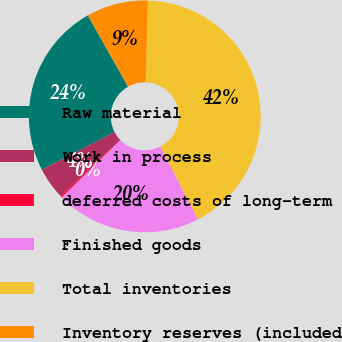Convert chart. <chart><loc_0><loc_0><loc_500><loc_500><pie_chart><fcel>Raw material<fcel>Work in process<fcel>deferred costs of long-term<fcel>Finished goods<fcel>Total inventories<fcel>Inventory reserves (included<nl><fcel>24.45%<fcel>4.43%<fcel>0.26%<fcel>20.28%<fcel>41.97%<fcel>8.6%<nl></chart> 